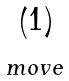<formula> <loc_0><loc_0><loc_500><loc_500>\begin{matrix} \left ( 1 \right ) \\ _ { m o v e } \end{matrix}</formula> 